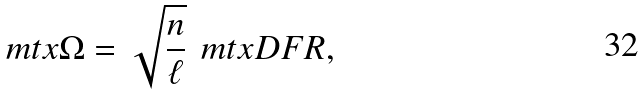<formula> <loc_0><loc_0><loc_500><loc_500>\ m t x { \Omega } = \sqrt { \frac { n } { \ell } } \, \ m t x { D F R } ,</formula> 